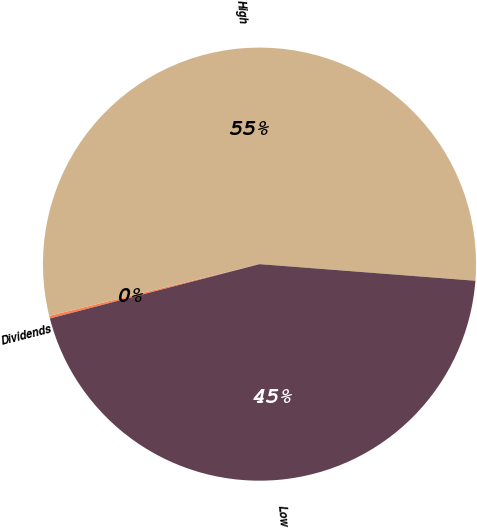Convert chart. <chart><loc_0><loc_0><loc_500><loc_500><pie_chart><fcel>Dividends<fcel>High<fcel>Low<nl><fcel>0.2%<fcel>55.06%<fcel>44.74%<nl></chart> 